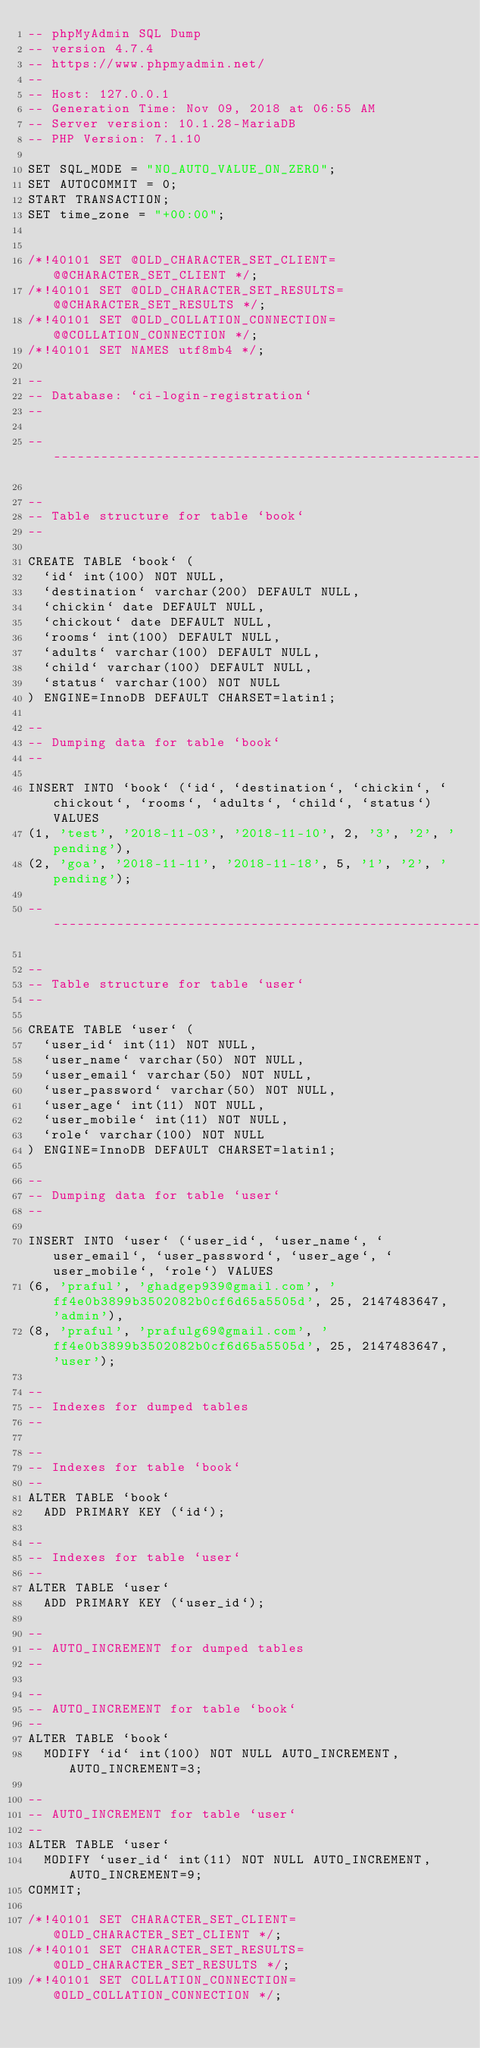<code> <loc_0><loc_0><loc_500><loc_500><_SQL_>-- phpMyAdmin SQL Dump
-- version 4.7.4
-- https://www.phpmyadmin.net/
--
-- Host: 127.0.0.1
-- Generation Time: Nov 09, 2018 at 06:55 AM
-- Server version: 10.1.28-MariaDB
-- PHP Version: 7.1.10

SET SQL_MODE = "NO_AUTO_VALUE_ON_ZERO";
SET AUTOCOMMIT = 0;
START TRANSACTION;
SET time_zone = "+00:00";


/*!40101 SET @OLD_CHARACTER_SET_CLIENT=@@CHARACTER_SET_CLIENT */;
/*!40101 SET @OLD_CHARACTER_SET_RESULTS=@@CHARACTER_SET_RESULTS */;
/*!40101 SET @OLD_COLLATION_CONNECTION=@@COLLATION_CONNECTION */;
/*!40101 SET NAMES utf8mb4 */;

--
-- Database: `ci-login-registration`
--

-- --------------------------------------------------------

--
-- Table structure for table `book`
--

CREATE TABLE `book` (
  `id` int(100) NOT NULL,
  `destination` varchar(200) DEFAULT NULL,
  `chickin` date DEFAULT NULL,
  `chickout` date DEFAULT NULL,
  `rooms` int(100) DEFAULT NULL,
  `adults` varchar(100) DEFAULT NULL,
  `child` varchar(100) DEFAULT NULL,
  `status` varchar(100) NOT NULL
) ENGINE=InnoDB DEFAULT CHARSET=latin1;

--
-- Dumping data for table `book`
--

INSERT INTO `book` (`id`, `destination`, `chickin`, `chickout`, `rooms`, `adults`, `child`, `status`) VALUES
(1, 'test', '2018-11-03', '2018-11-10', 2, '3', '2', 'pending'),
(2, 'goa', '2018-11-11', '2018-11-18', 5, '1', '2', 'pending');

-- --------------------------------------------------------

--
-- Table structure for table `user`
--

CREATE TABLE `user` (
  `user_id` int(11) NOT NULL,
  `user_name` varchar(50) NOT NULL,
  `user_email` varchar(50) NOT NULL,
  `user_password` varchar(50) NOT NULL,
  `user_age` int(11) NOT NULL,
  `user_mobile` int(11) NOT NULL,
  `role` varchar(100) NOT NULL
) ENGINE=InnoDB DEFAULT CHARSET=latin1;

--
-- Dumping data for table `user`
--

INSERT INTO `user` (`user_id`, `user_name`, `user_email`, `user_password`, `user_age`, `user_mobile`, `role`) VALUES
(6, 'praful', 'ghadgep939@gmail.com', 'ff4e0b3899b3502082b0cf6d65a5505d', 25, 2147483647, 'admin'),
(8, 'praful', 'prafulg69@gmail.com', 'ff4e0b3899b3502082b0cf6d65a5505d', 25, 2147483647, 'user');

--
-- Indexes for dumped tables
--

--
-- Indexes for table `book`
--
ALTER TABLE `book`
  ADD PRIMARY KEY (`id`);

--
-- Indexes for table `user`
--
ALTER TABLE `user`
  ADD PRIMARY KEY (`user_id`);

--
-- AUTO_INCREMENT for dumped tables
--

--
-- AUTO_INCREMENT for table `book`
--
ALTER TABLE `book`
  MODIFY `id` int(100) NOT NULL AUTO_INCREMENT, AUTO_INCREMENT=3;

--
-- AUTO_INCREMENT for table `user`
--
ALTER TABLE `user`
  MODIFY `user_id` int(11) NOT NULL AUTO_INCREMENT, AUTO_INCREMENT=9;
COMMIT;

/*!40101 SET CHARACTER_SET_CLIENT=@OLD_CHARACTER_SET_CLIENT */;
/*!40101 SET CHARACTER_SET_RESULTS=@OLD_CHARACTER_SET_RESULTS */;
/*!40101 SET COLLATION_CONNECTION=@OLD_COLLATION_CONNECTION */;
</code> 